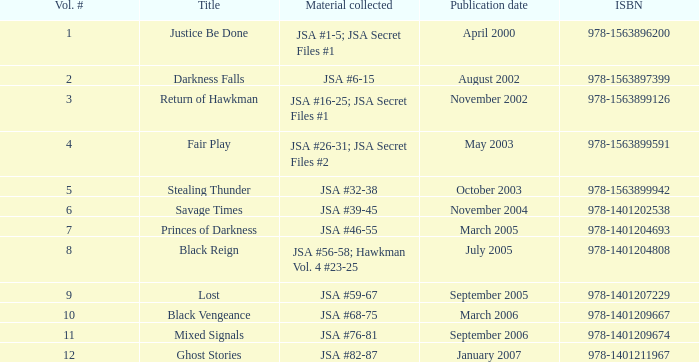What's the material compiled for the 978-1401209674 isbn? JSA #76-81. 